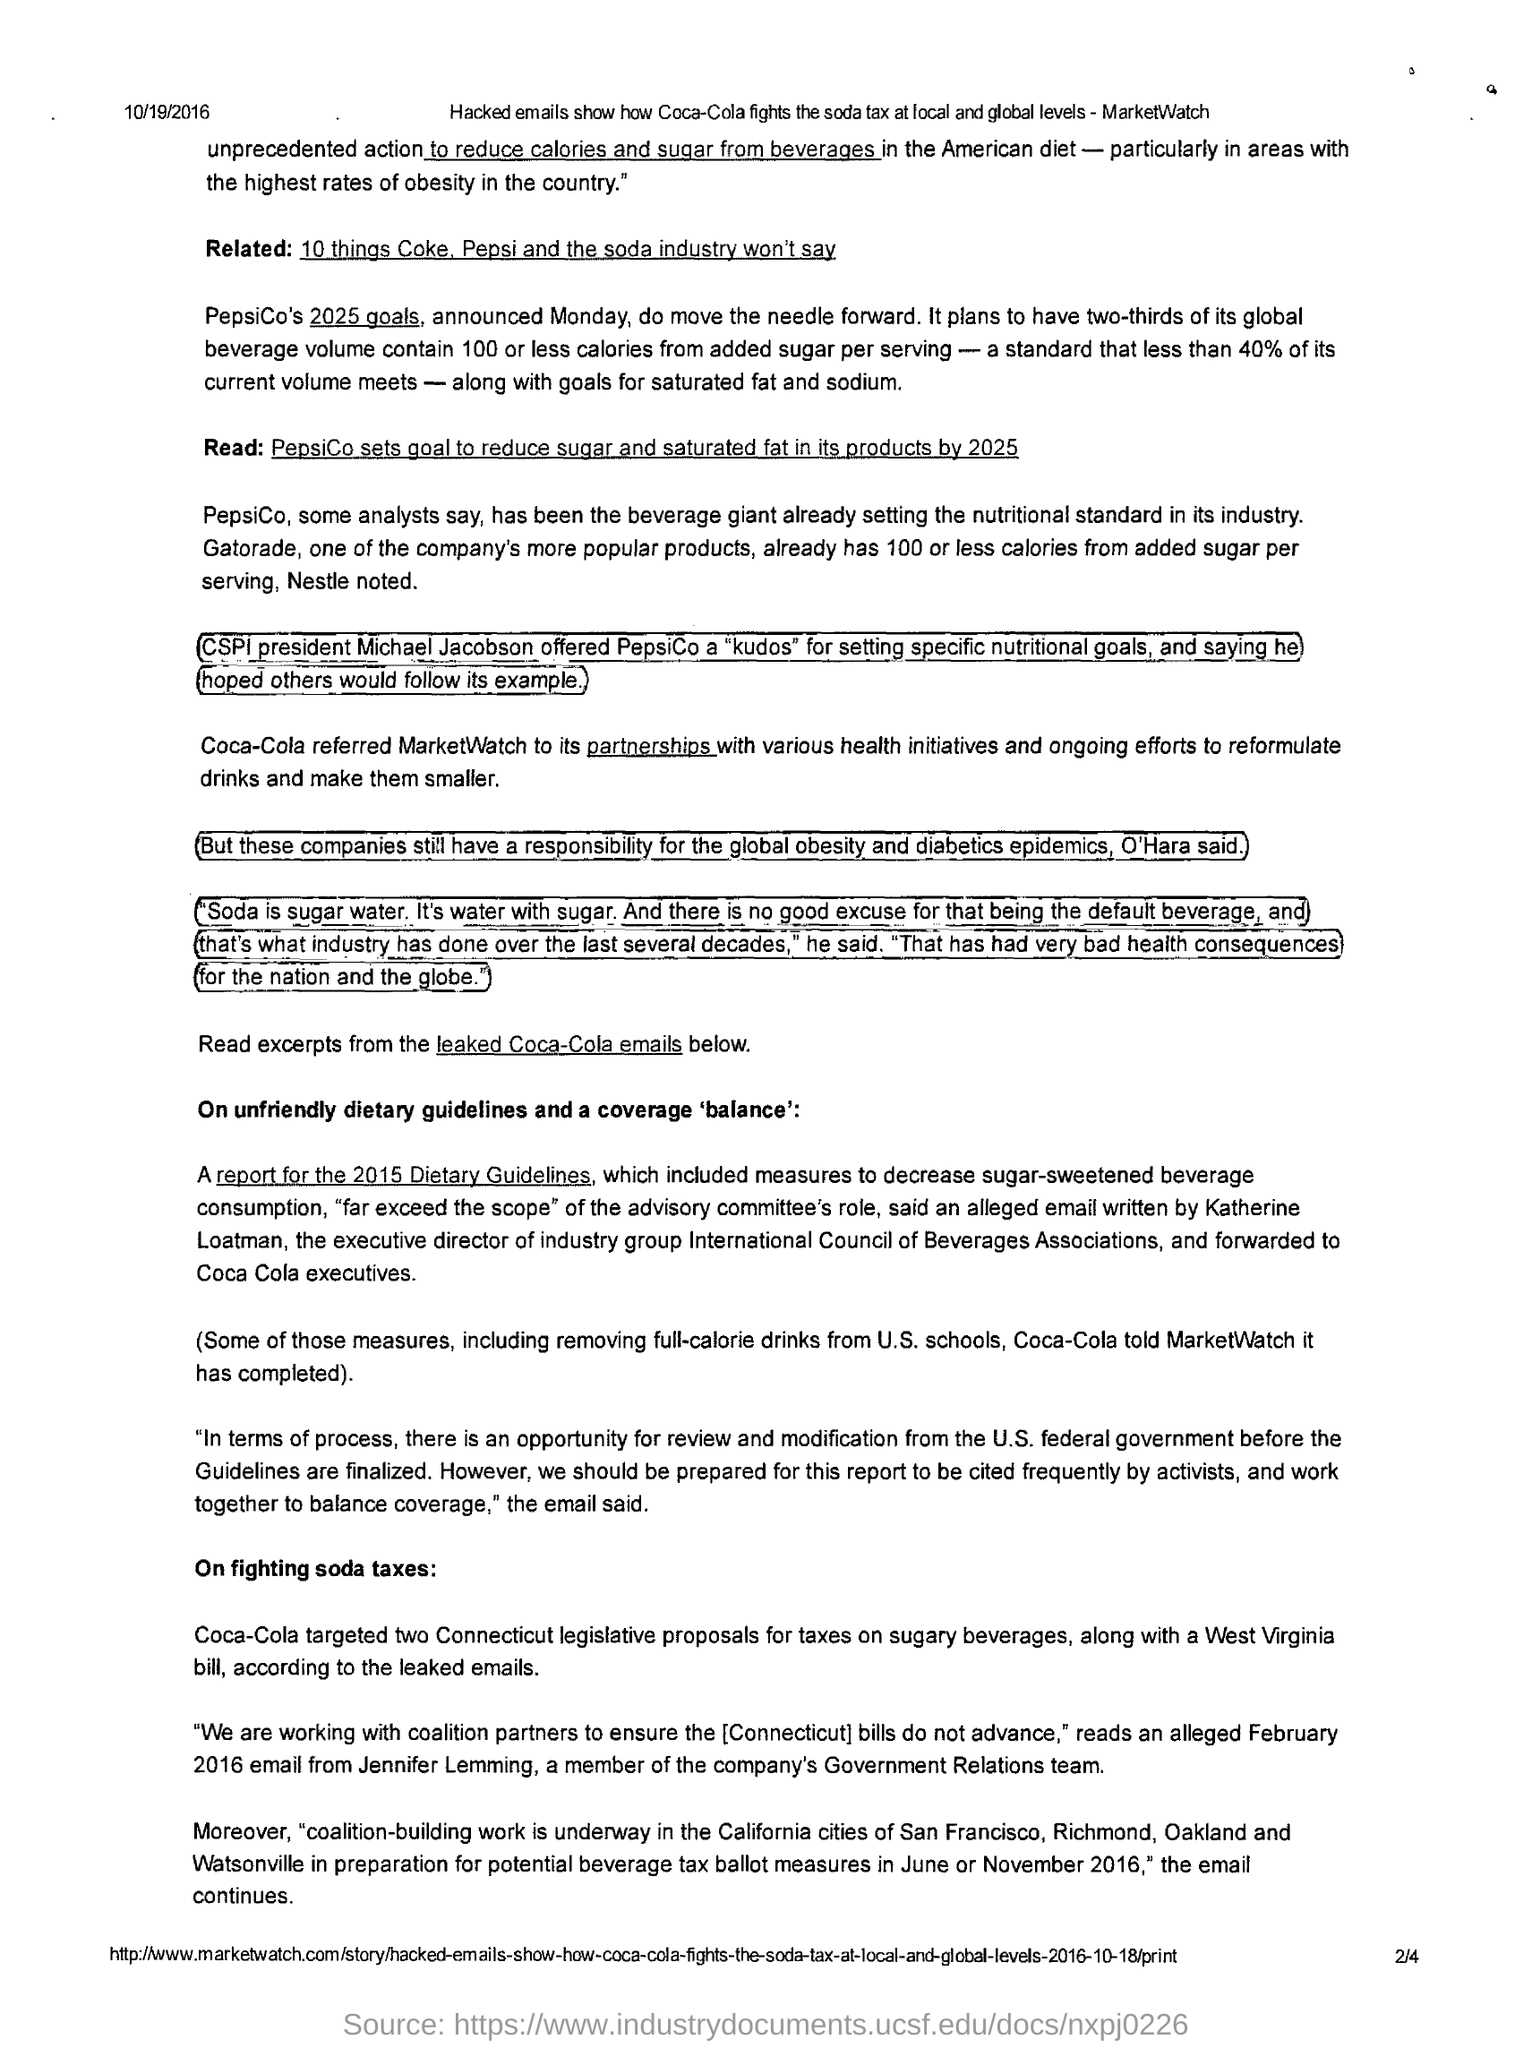What is the date mentioned in the header of the document?
Provide a succinct answer. 10/19/2016. Coca-Cola targeted how many Connecticut legislative proposals for taxes on beverages?
Your answer should be very brief. Two. 